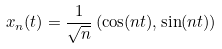<formula> <loc_0><loc_0><loc_500><loc_500>x _ { n } ( t ) = \frac { 1 } { \sqrt { n } } \left ( \cos ( n t ) , \sin ( n t ) \right )</formula> 